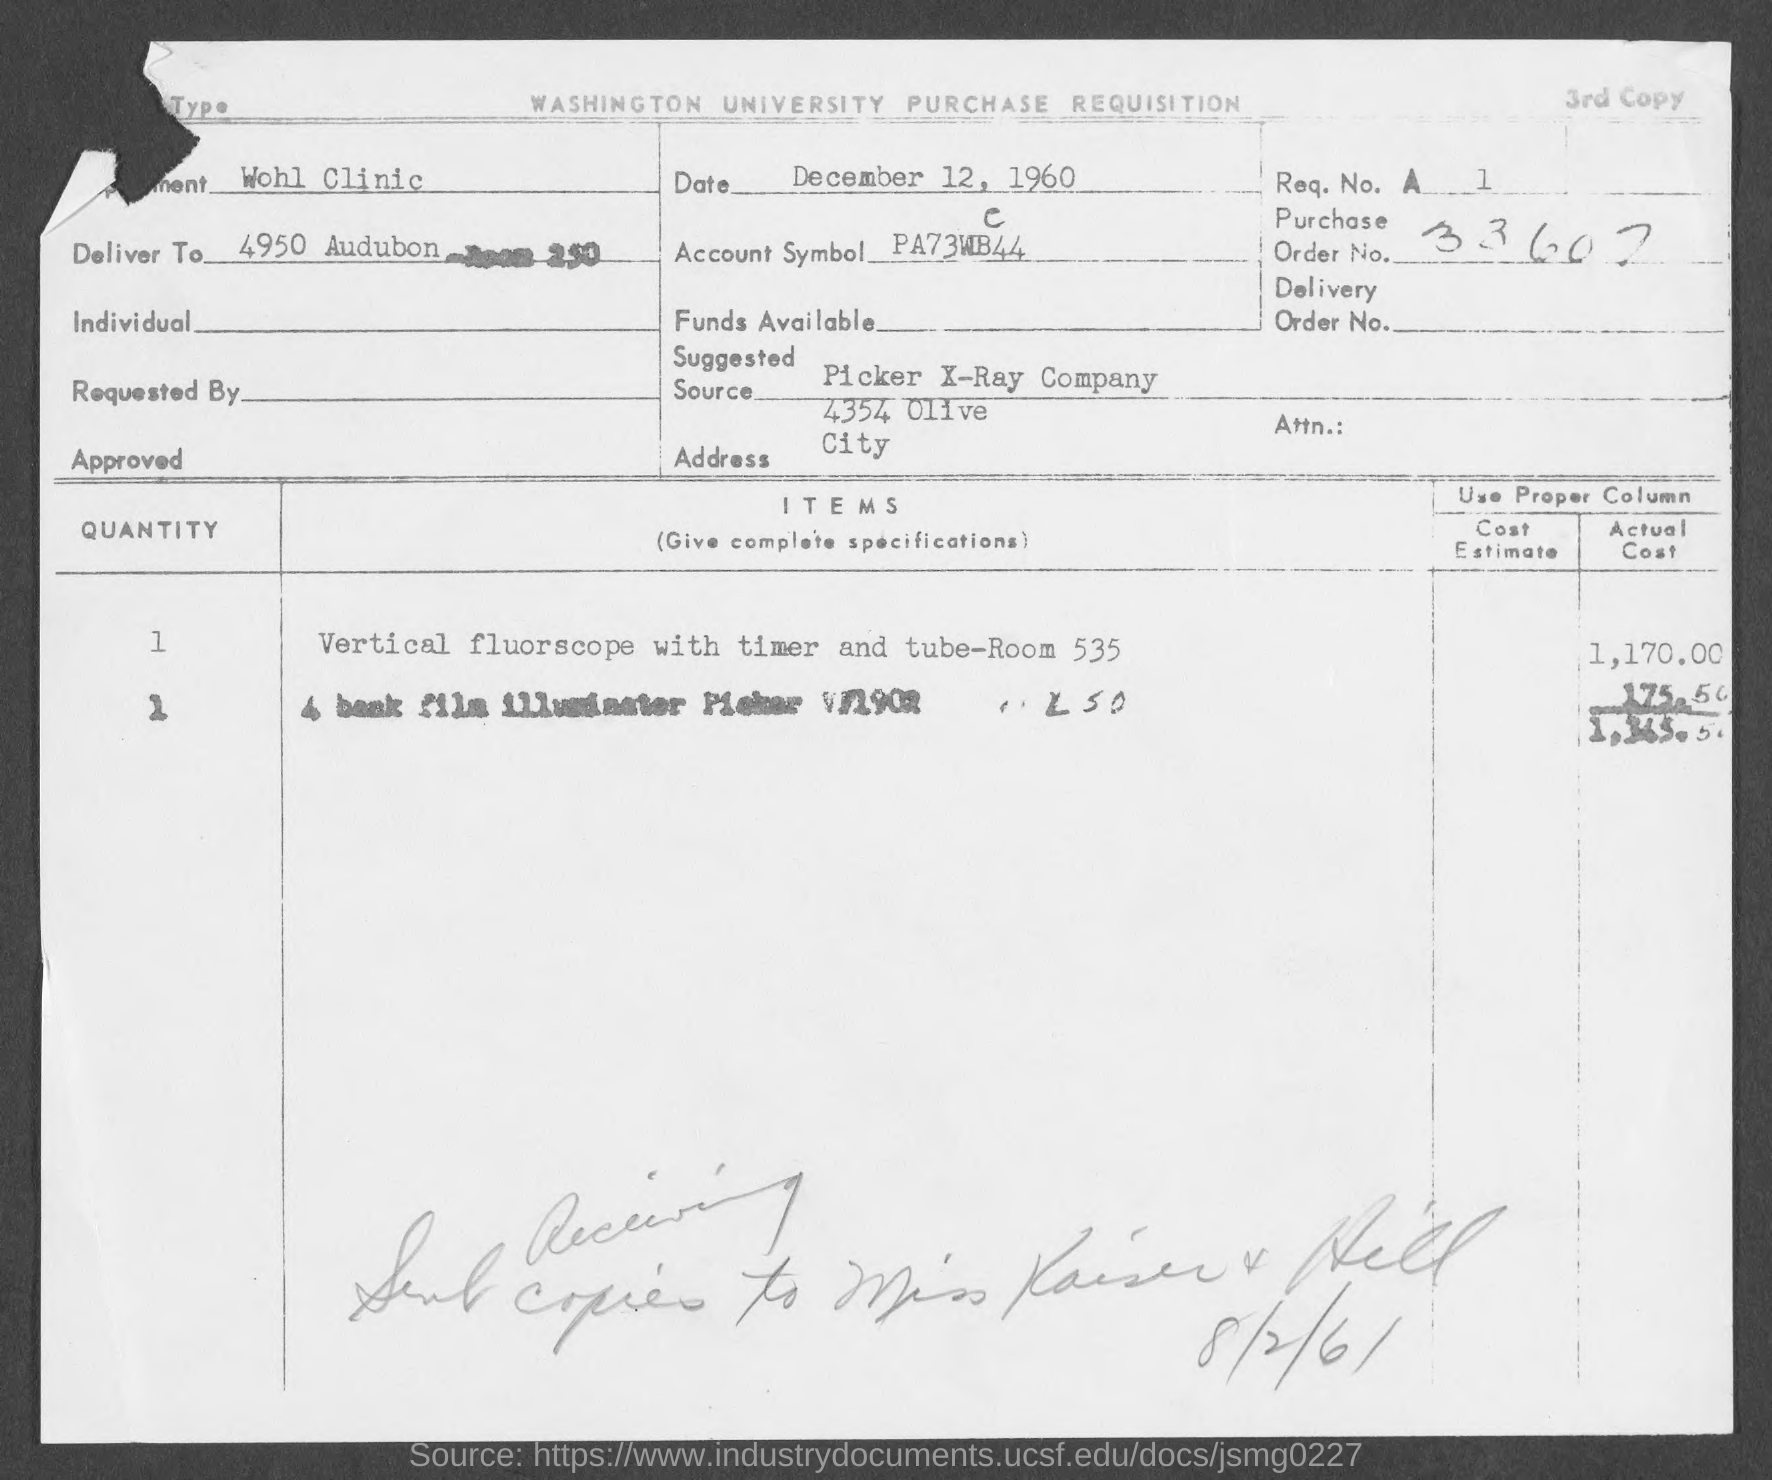What is the department?
Your answer should be very brief. Wohl Clinic. What is the Date?
Provide a succinct answer. December 12, 1960. What is the Purchase order No.?
Keep it short and to the point. 33607. What is the suggested source?
Ensure brevity in your answer.  Picker X-Ray Company. What is the address?
Your answer should be very brief. 4354 Olive City. What is the Actual cost?
Your answer should be very brief. 1,365.50. 